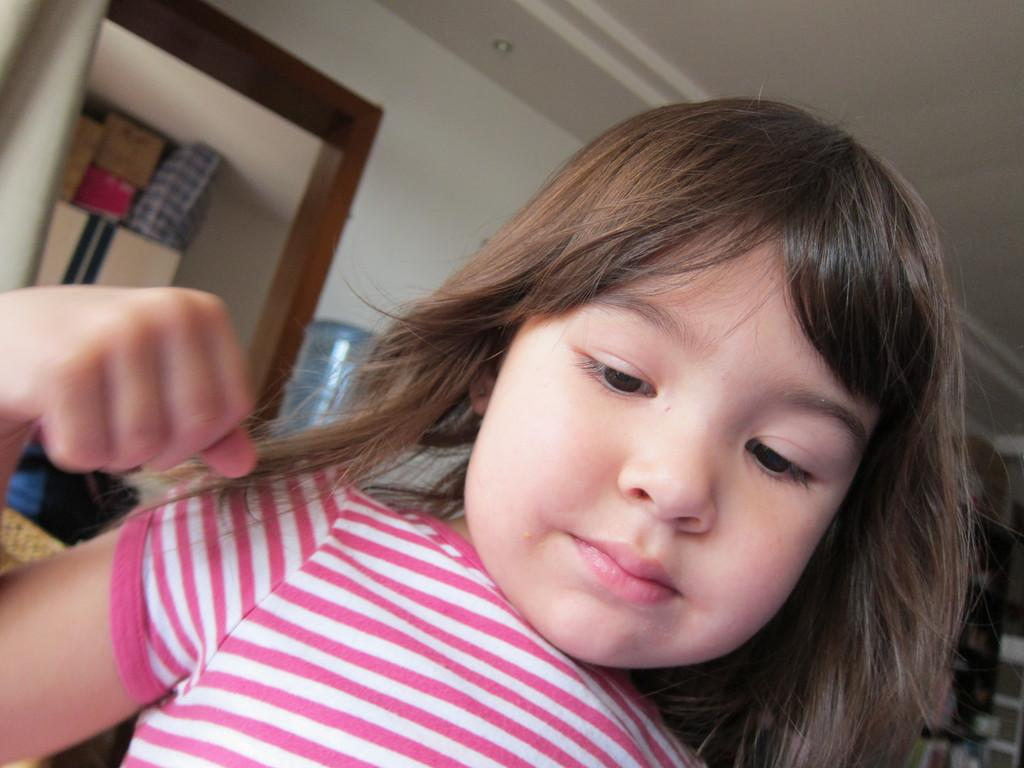What is the main subject in the foreground of the image? There is a small girl in the foreground of the image. What can be seen in the background of the image? There are cupboards and other objects in the background of the image. What type of government is depicted in the image? There is no depiction of a government in the image; it features a small girl in the foreground and cupboards in the background. 